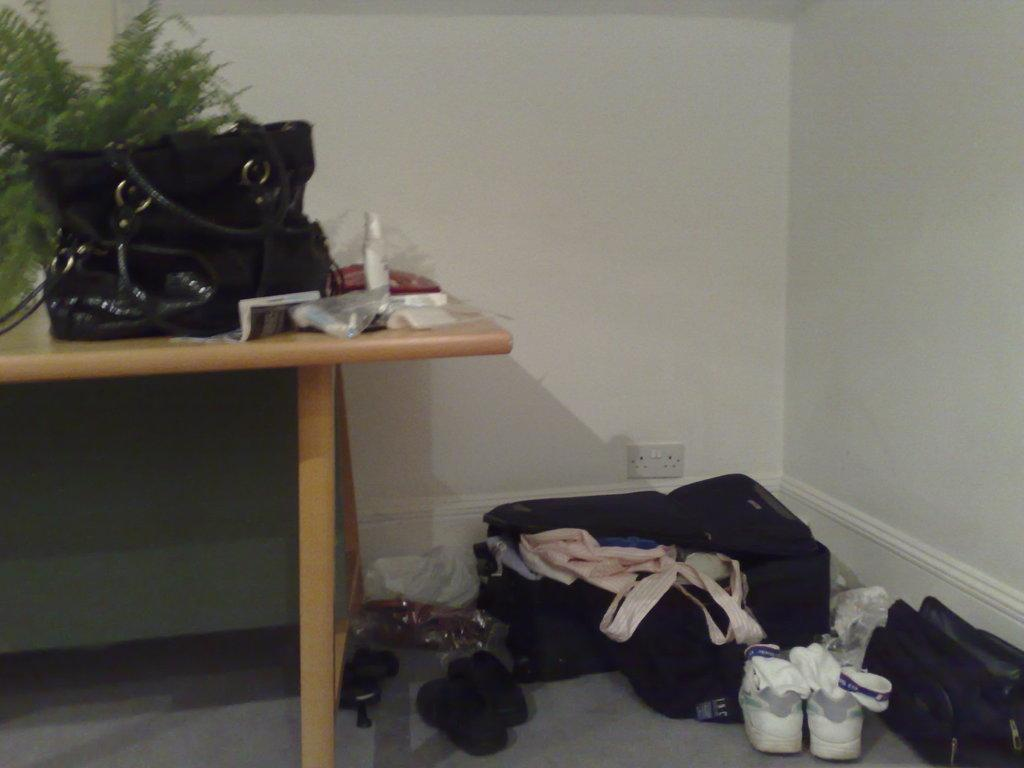What is the color of the wall in the image? The wall in the image is white. What piece of furniture is present in the image? There is a table in the image. What objects are on the table? There is a bottle and a black color handbag on the table. What is on the floor in the image? There is a suitcase and shoes on the floor. How many quinces are on the table in the image? There are no quinces present in the image. Is there a bat flying in the image? There is no bat visible in the image. 